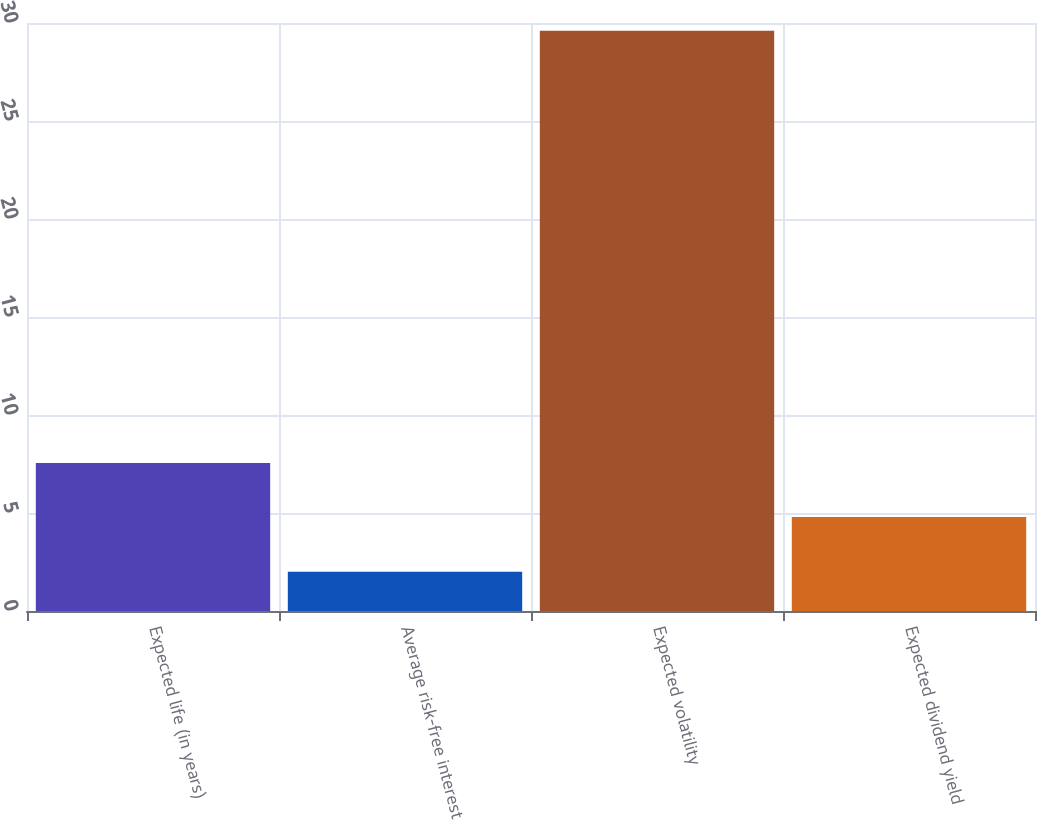Convert chart. <chart><loc_0><loc_0><loc_500><loc_500><bar_chart><fcel>Expected life (in years)<fcel>Average risk-free interest<fcel>Expected volatility<fcel>Expected dividend yield<nl><fcel>7.55<fcel>2<fcel>29.6<fcel>4.79<nl></chart> 